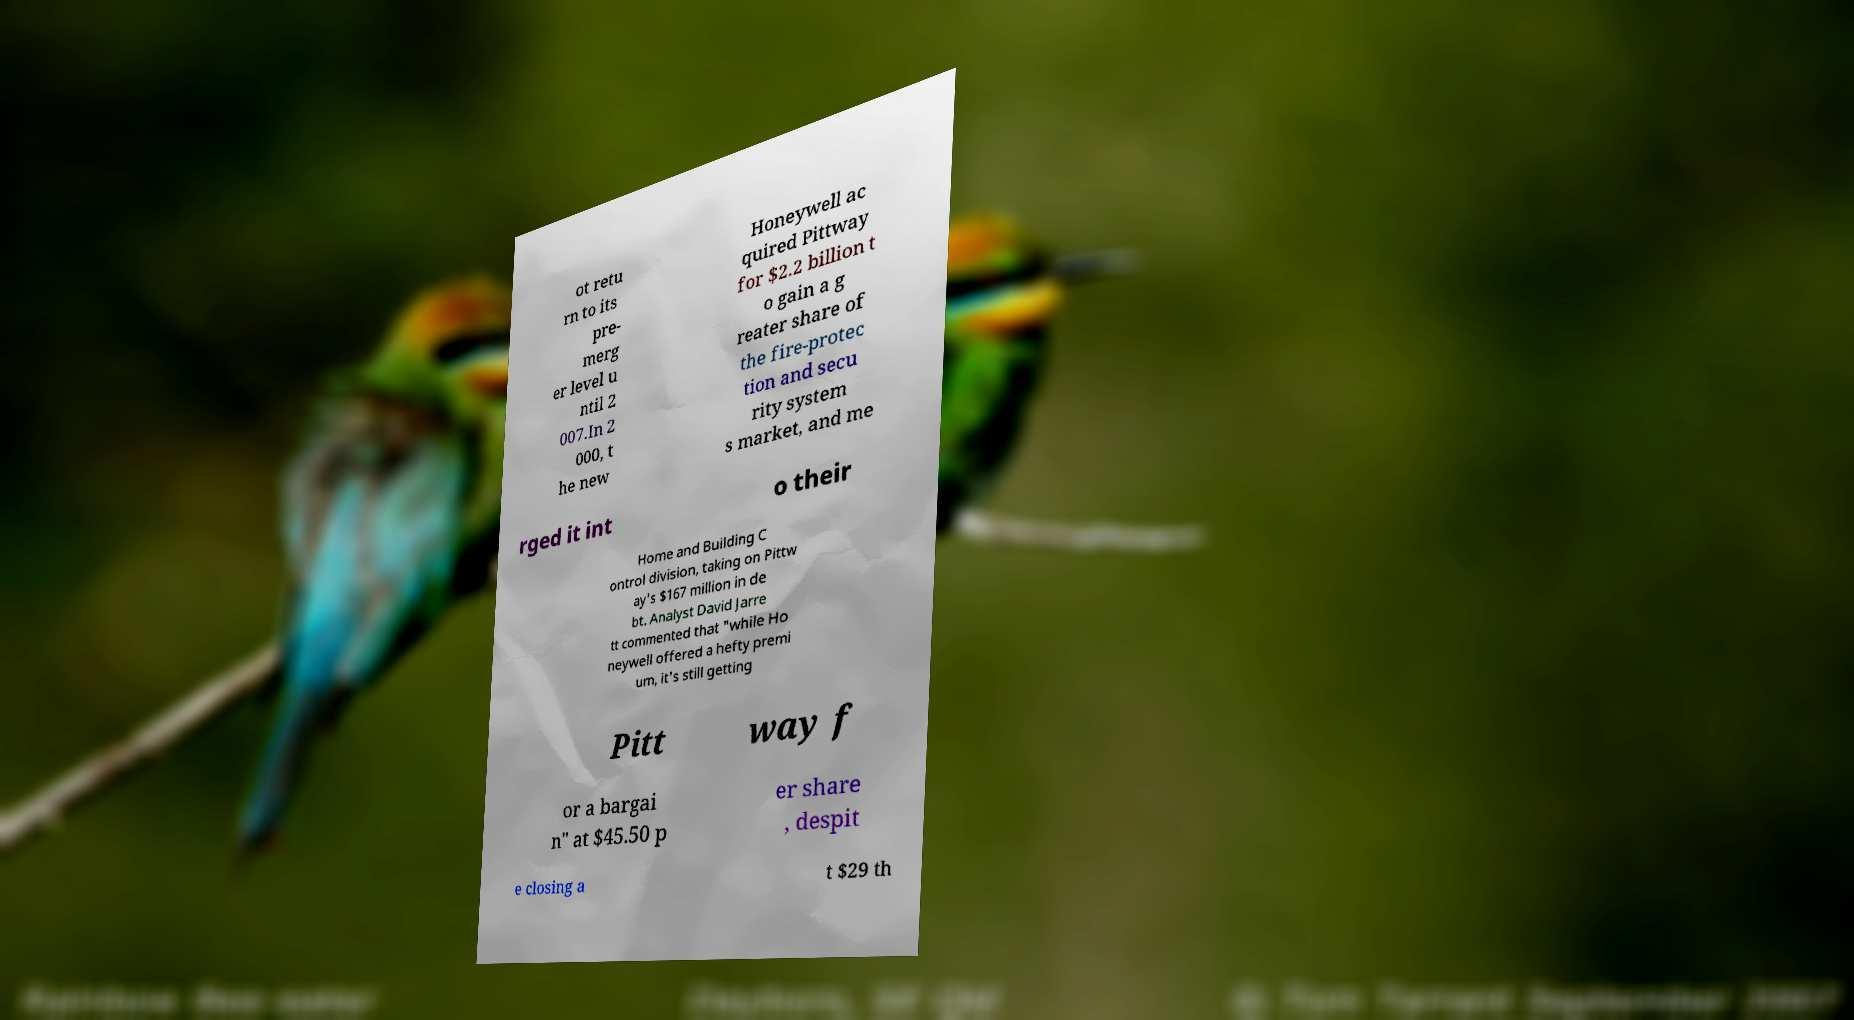There's text embedded in this image that I need extracted. Can you transcribe it verbatim? ot retu rn to its pre- merg er level u ntil 2 007.In 2 000, t he new Honeywell ac quired Pittway for $2.2 billion t o gain a g reater share of the fire-protec tion and secu rity system s market, and me rged it int o their Home and Building C ontrol division, taking on Pittw ay's $167 million in de bt. Analyst David Jarre tt commented that "while Ho neywell offered a hefty premi um, it's still getting Pitt way f or a bargai n" at $45.50 p er share , despit e closing a t $29 th 